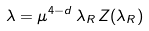<formula> <loc_0><loc_0><loc_500><loc_500>\lambda = \mu ^ { 4 - d } \, \lambda _ { R } \, Z ( \lambda _ { R } )</formula> 